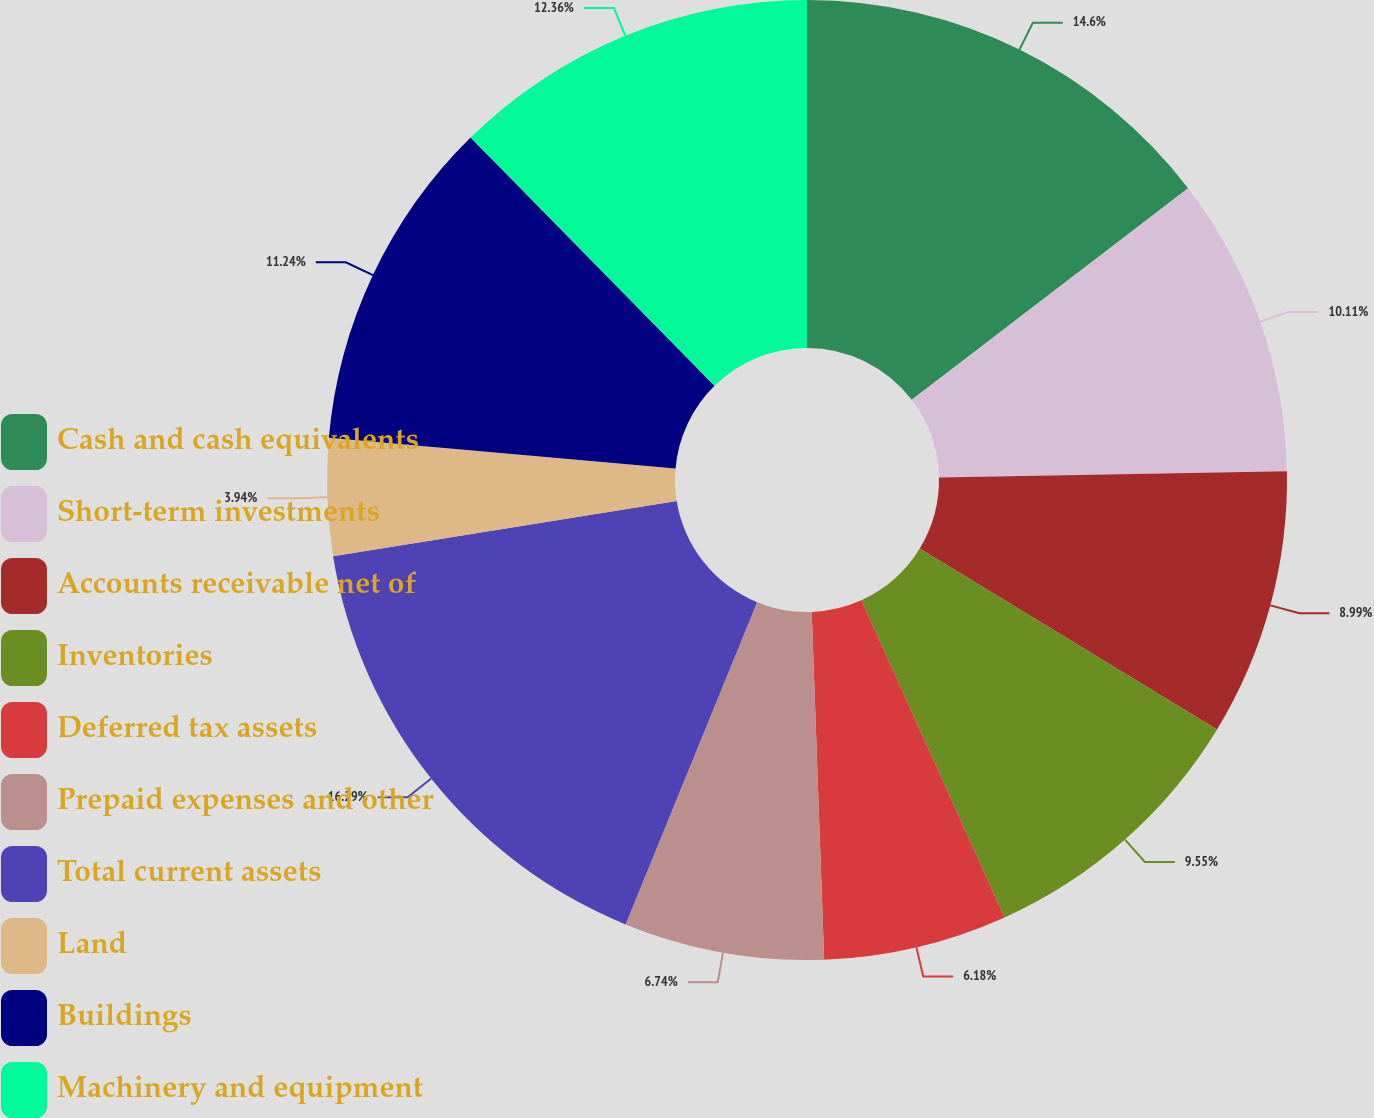Convert chart to OTSL. <chart><loc_0><loc_0><loc_500><loc_500><pie_chart><fcel>Cash and cash equivalents<fcel>Short-term investments<fcel>Accounts receivable net of<fcel>Inventories<fcel>Deferred tax assets<fcel>Prepaid expenses and other<fcel>Total current assets<fcel>Land<fcel>Buildings<fcel>Machinery and equipment<nl><fcel>14.6%<fcel>10.11%<fcel>8.99%<fcel>9.55%<fcel>6.18%<fcel>6.74%<fcel>16.29%<fcel>3.94%<fcel>11.24%<fcel>12.36%<nl></chart> 